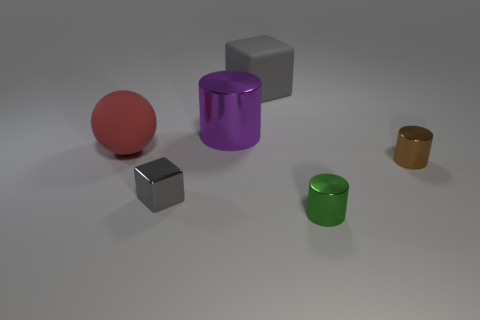The rubber object that is the same color as the small cube is what size?
Your answer should be very brief. Large. There is a large rubber object that is behind the large rubber object in front of the gray rubber block that is behind the small green cylinder; what is its shape?
Ensure brevity in your answer.  Cube. Is there another gray object that has the same size as the gray rubber object?
Keep it short and to the point. No. The brown metallic thing is what size?
Keep it short and to the point. Small. How many other cubes are the same size as the gray shiny cube?
Your answer should be compact. 0. Are there fewer small metallic cubes that are right of the matte ball than tiny metal objects that are on the right side of the large gray object?
Provide a succinct answer. Yes. There is a gray cube that is behind the big purple object that is behind the tiny green shiny cylinder that is in front of the large purple metallic thing; what size is it?
Provide a succinct answer. Large. There is a thing that is in front of the large metallic cylinder and behind the small brown metal cylinder; what size is it?
Make the answer very short. Large. What shape is the rubber object that is in front of the block that is behind the big red rubber ball?
Offer a very short reply. Sphere. Is there anything else of the same color as the large rubber cube?
Give a very brief answer. Yes. 